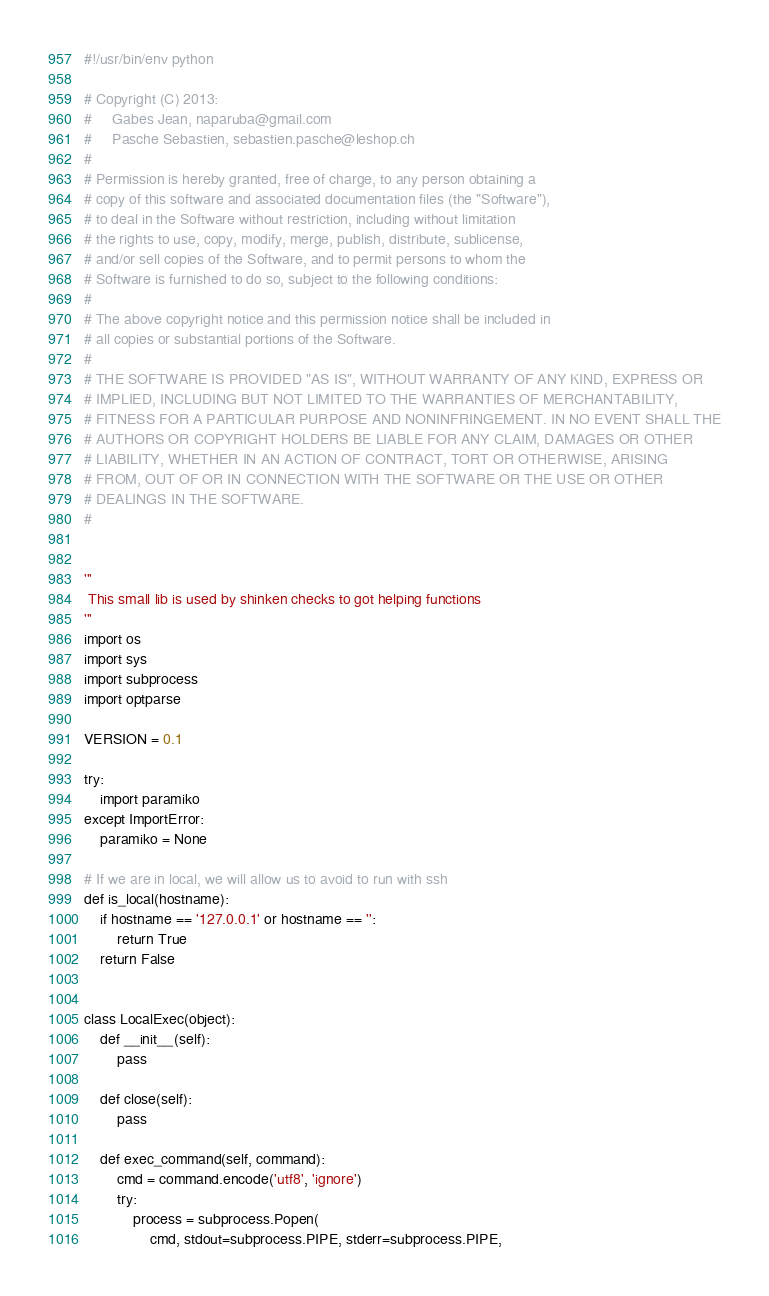<code> <loc_0><loc_0><loc_500><loc_500><_Python_>#!/usr/bin/env python

# Copyright (C) 2013:
#     Gabes Jean, naparuba@gmail.com
#     Pasche Sebastien, sebastien.pasche@leshop.ch
# 
# Permission is hereby granted, free of charge, to any person obtaining a
# copy of this software and associated documentation files (the "Software"), 
# to deal in the Software without restriction, including without limitation 
# the rights to use, copy, modify, merge, publish, distribute, sublicense, 
# and/or sell copies of the Software, and to permit persons to whom the 
# Software is furnished to do so, subject to the following conditions:
#   
# The above copyright notice and this permission notice shall be included in
# all copies or substantial portions of the Software.
#   
# THE SOFTWARE IS PROVIDED "AS IS", WITHOUT WARRANTY OF ANY KIND, EXPRESS OR
# IMPLIED, INCLUDING BUT NOT LIMITED TO THE WARRANTIES OF MERCHANTABILITY, 
# FITNESS FOR A PARTICULAR PURPOSE AND NONINFRINGEMENT. IN NO EVENT SHALL THE
# AUTHORS OR COPYRIGHT HOLDERS BE LIABLE FOR ANY CLAIM, DAMAGES OR OTHER 
# LIABILITY, WHETHER IN AN ACTION OF CONTRACT, TORT OR OTHERWISE, ARISING 
# FROM, OUT OF OR IN CONNECTION WITH THE SOFTWARE OR THE USE OR OTHER 
# DEALINGS IN THE SOFTWARE.
#  


'''
 This small lib is used by shinken checks to got helping functions
'''
import os
import sys
import subprocess
import optparse

VERSION = 0.1

try:
    import paramiko
except ImportError:
    paramiko = None

# If we are in local, we will allow us to avoid to run with ssh
def is_local(hostname):
    if hostname == '127.0.0.1' or hostname == '':
        return True
    return False


class LocalExec(object):
    def __init__(self):
        pass

    def close(self):
        pass

    def exec_command(self, command):
        cmd = command.encode('utf8', 'ignore')
        try:
            process = subprocess.Popen(
                cmd, stdout=subprocess.PIPE, stderr=subprocess.PIPE,</code> 